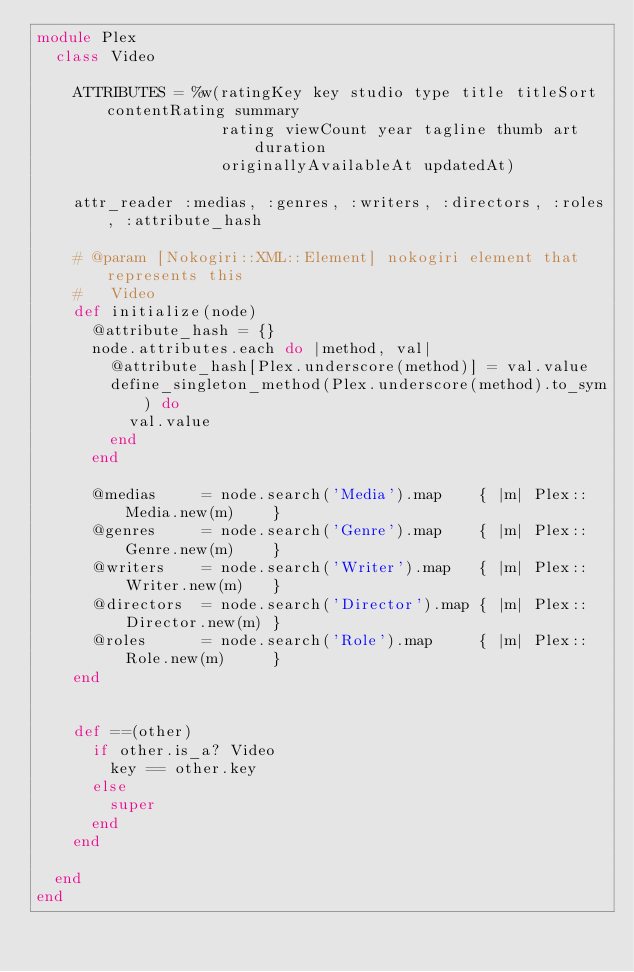Convert code to text. <code><loc_0><loc_0><loc_500><loc_500><_Ruby_>module Plex
  class Video

    ATTRIBUTES = %w(ratingKey key studio type title titleSort contentRating summary
                    rating viewCount year tagline thumb art duration
                    originallyAvailableAt updatedAt)

    attr_reader :medias, :genres, :writers, :directors, :roles, :attribute_hash

    # @param [Nokogiri::XML::Element] nokogiri element that represents this
    #   Video
    def initialize(node)
      @attribute_hash = {}
      node.attributes.each do |method, val|
        @attribute_hash[Plex.underscore(method)] = val.value
        define_singleton_method(Plex.underscore(method).to_sym) do
          val.value
        end
      end

      @medias     = node.search('Media').map    { |m| Plex::Media.new(m)    }
      @genres     = node.search('Genre').map    { |m| Plex::Genre.new(m)    }
      @writers    = node.search('Writer').map   { |m| Plex::Writer.new(m)   }
      @directors  = node.search('Director').map { |m| Plex::Director.new(m) }
      @roles      = node.search('Role').map     { |m| Plex::Role.new(m)     }
    end


    def ==(other)
      if other.is_a? Video
        key == other.key
      else
        super
      end
    end

  end
end
</code> 